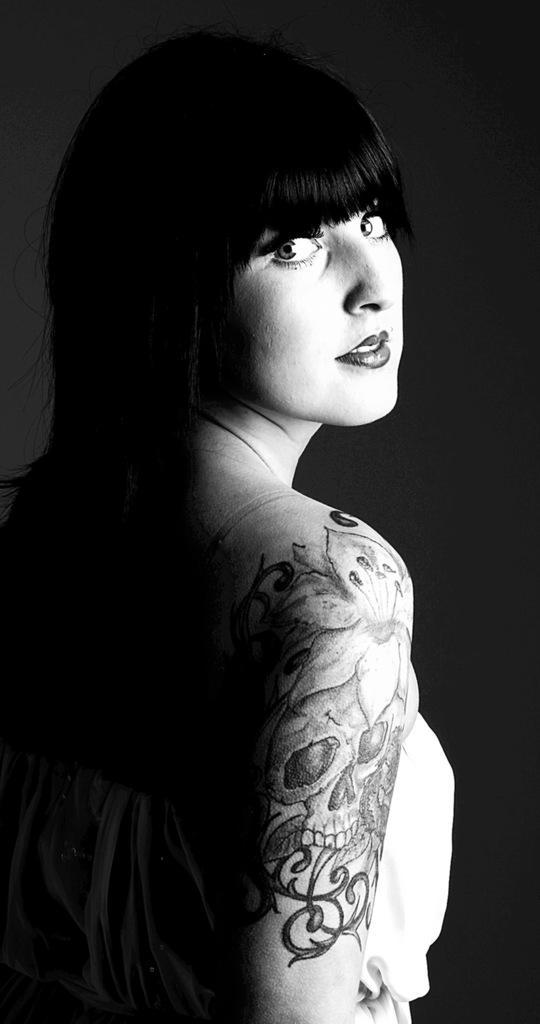Can you describe this image briefly? In this picture I can see a woman in front who is standing and I see tattoos on her hand and I see that this is a black and white image. 